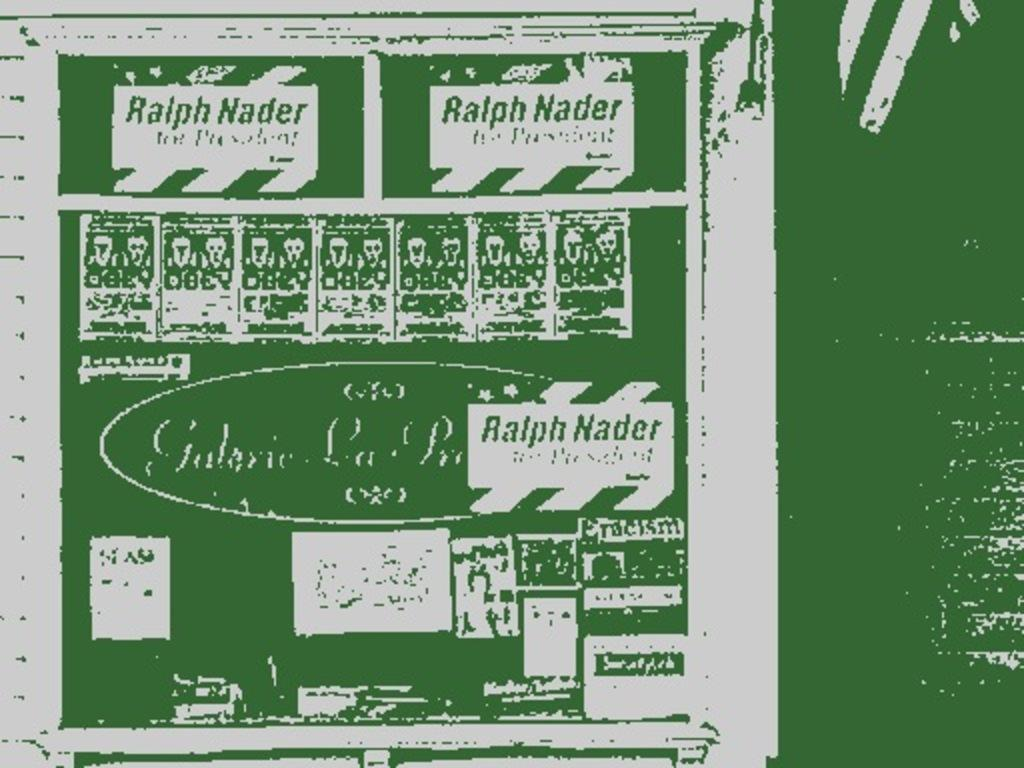<image>
Summarize the visual content of the image. Some kind of green white poster showing Ralph Nader on it 